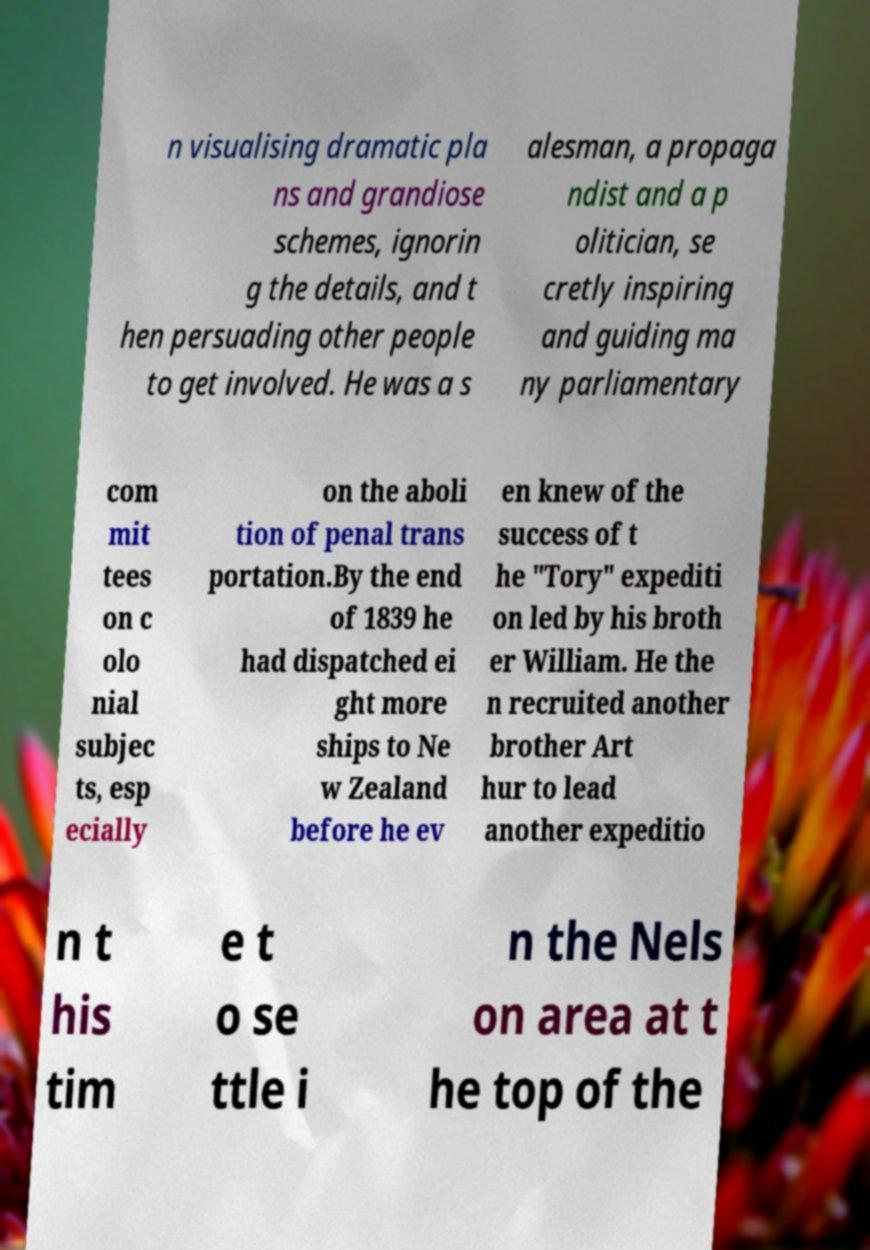For documentation purposes, I need the text within this image transcribed. Could you provide that? n visualising dramatic pla ns and grandiose schemes, ignorin g the details, and t hen persuading other people to get involved. He was a s alesman, a propaga ndist and a p olitician, se cretly inspiring and guiding ma ny parliamentary com mit tees on c olo nial subjec ts, esp ecially on the aboli tion of penal trans portation.By the end of 1839 he had dispatched ei ght more ships to Ne w Zealand before he ev en knew of the success of t he "Tory" expediti on led by his broth er William. He the n recruited another brother Art hur to lead another expeditio n t his tim e t o se ttle i n the Nels on area at t he top of the 